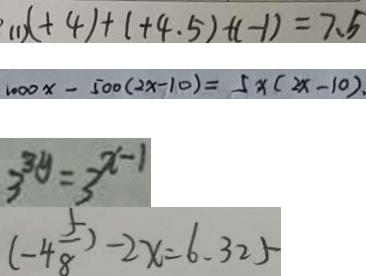<formula> <loc_0><loc_0><loc_500><loc_500>( 1 ) ( + 4 ) + ( + 4 . 5 ) + ( - 1 ) = 7 . 5 
 1 0 0 0 x - 5 0 0 ( 2 x - 1 0 ) = 5 x ( 2 x - 1 0 ) . 
 3 ^ { 3 y } = 3 ^ { x - 1 } 
 ( - 4 \frac { 5 } { 8 } ) - 2 x = 6 . 3 2 5</formula> 